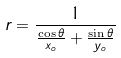<formula> <loc_0><loc_0><loc_500><loc_500>r = \frac { 1 } { \frac { \cos \theta } { x _ { o } } + \frac { \sin \theta } { y _ { o } } }</formula> 